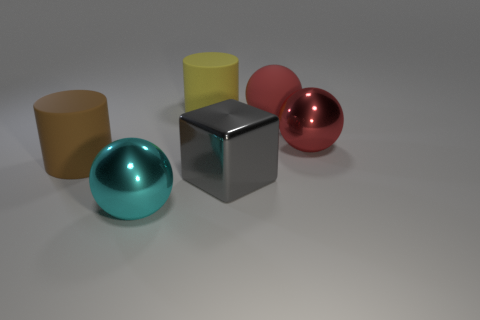Subtract all rubber spheres. How many spheres are left? 2 Add 1 large cyan metallic spheres. How many objects exist? 7 Subtract all cyan spheres. How many spheres are left? 2 Subtract 1 yellow cylinders. How many objects are left? 5 Subtract all cubes. How many objects are left? 5 Subtract 1 blocks. How many blocks are left? 0 Subtract all purple cylinders. Subtract all brown blocks. How many cylinders are left? 2 Subtract all red cylinders. How many yellow cubes are left? 0 Subtract all cyan shiny objects. Subtract all spheres. How many objects are left? 2 Add 2 large metallic cubes. How many large metallic cubes are left? 3 